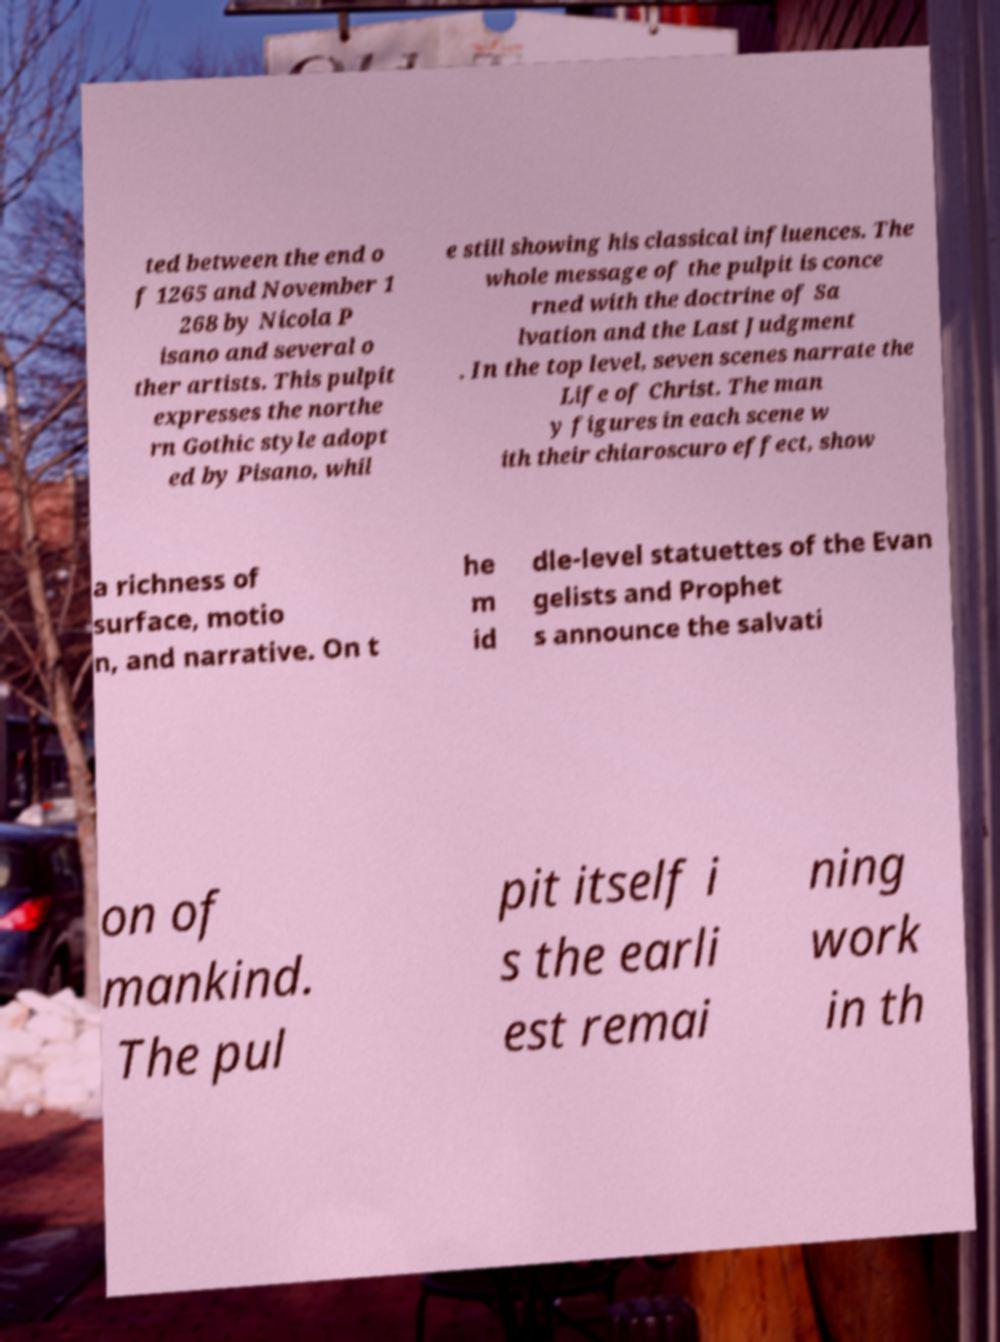What messages or text are displayed in this image? I need them in a readable, typed format. ted between the end o f 1265 and November 1 268 by Nicola P isano and several o ther artists. This pulpit expresses the northe rn Gothic style adopt ed by Pisano, whil e still showing his classical influences. The whole message of the pulpit is conce rned with the doctrine of Sa lvation and the Last Judgment . In the top level, seven scenes narrate the Life of Christ. The man y figures in each scene w ith their chiaroscuro effect, show a richness of surface, motio n, and narrative. On t he m id dle-level statuettes of the Evan gelists and Prophet s announce the salvati on of mankind. The pul pit itself i s the earli est remai ning work in th 